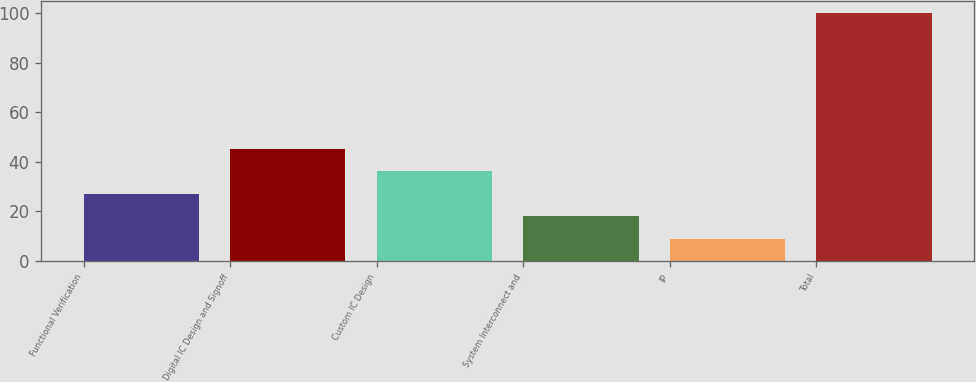Convert chart. <chart><loc_0><loc_0><loc_500><loc_500><bar_chart><fcel>Functional Verification<fcel>Digital IC Design and Signoff<fcel>Custom IC Design<fcel>System Interconnect and<fcel>IP<fcel>Total<nl><fcel>27.2<fcel>45.4<fcel>36.3<fcel>18.1<fcel>9<fcel>100<nl></chart> 